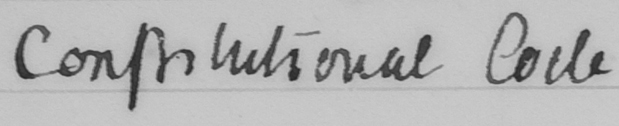Can you tell me what this handwritten text says? Constitutional Code 